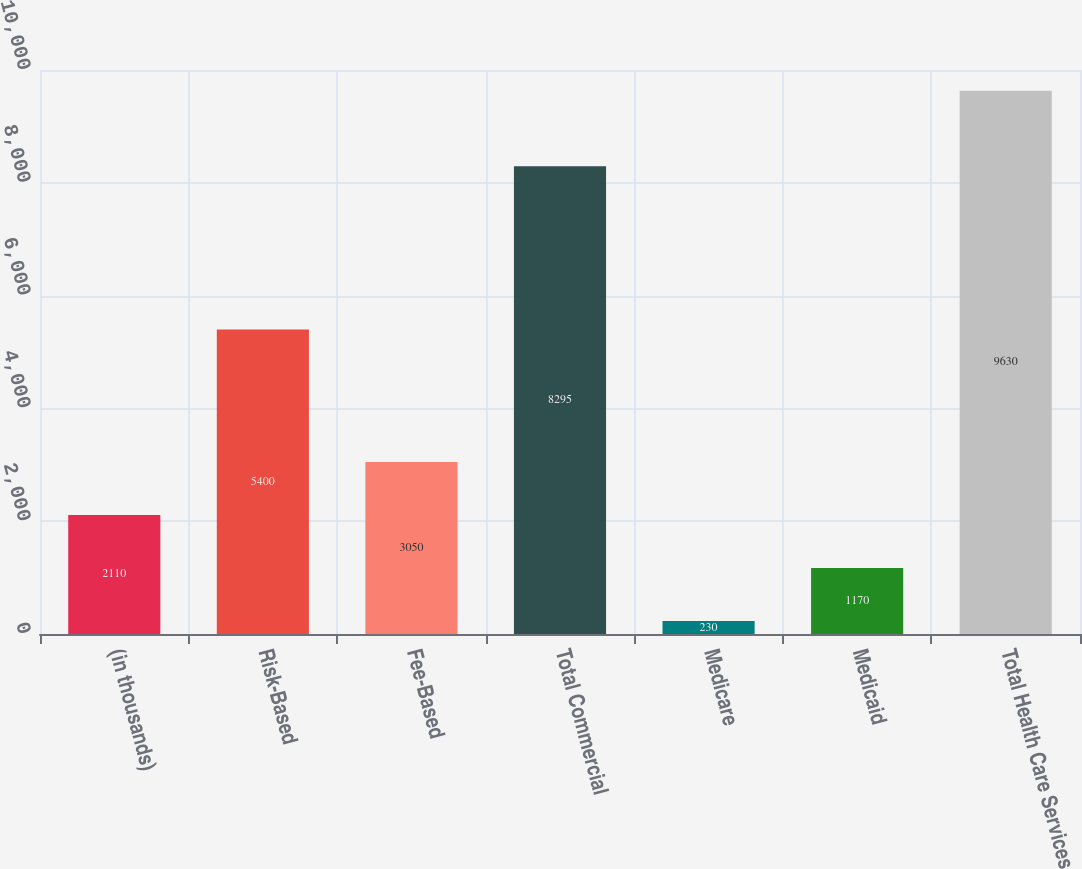<chart> <loc_0><loc_0><loc_500><loc_500><bar_chart><fcel>(in thousands)<fcel>Risk-Based<fcel>Fee-Based<fcel>Total Commercial<fcel>Medicare<fcel>Medicaid<fcel>Total Health Care Services<nl><fcel>2110<fcel>5400<fcel>3050<fcel>8295<fcel>230<fcel>1170<fcel>9630<nl></chart> 